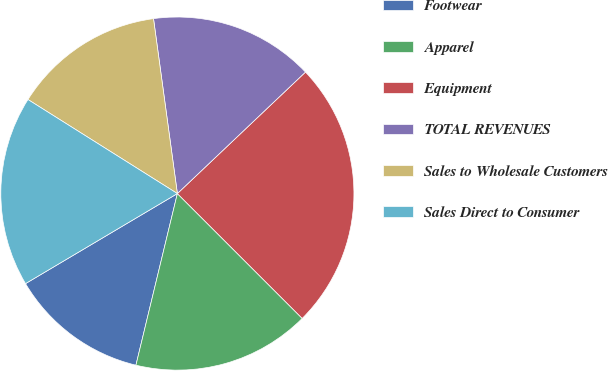Convert chart. <chart><loc_0><loc_0><loc_500><loc_500><pie_chart><fcel>Footwear<fcel>Apparel<fcel>Equipment<fcel>TOTAL REVENUES<fcel>Sales to Wholesale Customers<fcel>Sales Direct to Consumer<nl><fcel>12.71%<fcel>16.27%<fcel>24.58%<fcel>15.08%<fcel>13.9%<fcel>17.46%<nl></chart> 